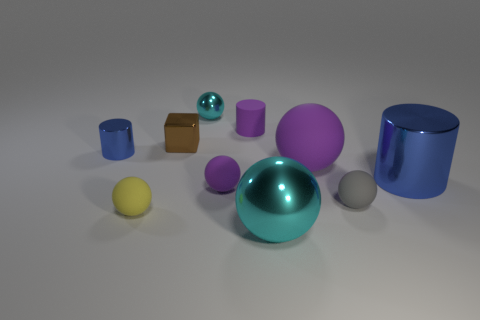Are there any gray rubber things of the same shape as the small yellow matte thing?
Your answer should be compact. Yes. Are there more large purple matte things that are in front of the tiny blue cylinder than gray blocks?
Ensure brevity in your answer.  Yes. How many rubber objects are small yellow things or cyan objects?
Your answer should be compact. 1. What size is the thing that is on the left side of the matte cylinder and in front of the gray rubber thing?
Make the answer very short. Small. There is a big sphere that is behind the big blue metal thing; are there any small rubber cylinders left of it?
Give a very brief answer. Yes. How many tiny spheres are on the right side of the tiny cyan sphere?
Ensure brevity in your answer.  2. There is a tiny metallic thing that is the same shape as the gray matte thing; what is its color?
Make the answer very short. Cyan. Does the tiny sphere in front of the gray rubber thing have the same material as the small ball behind the brown metal cube?
Provide a short and direct response. No. There is a tiny matte cylinder; is it the same color as the tiny cylinder that is on the left side of the yellow ball?
Your answer should be very brief. No. There is a object that is both behind the yellow thing and on the left side of the brown metallic object; what shape is it?
Give a very brief answer. Cylinder. 